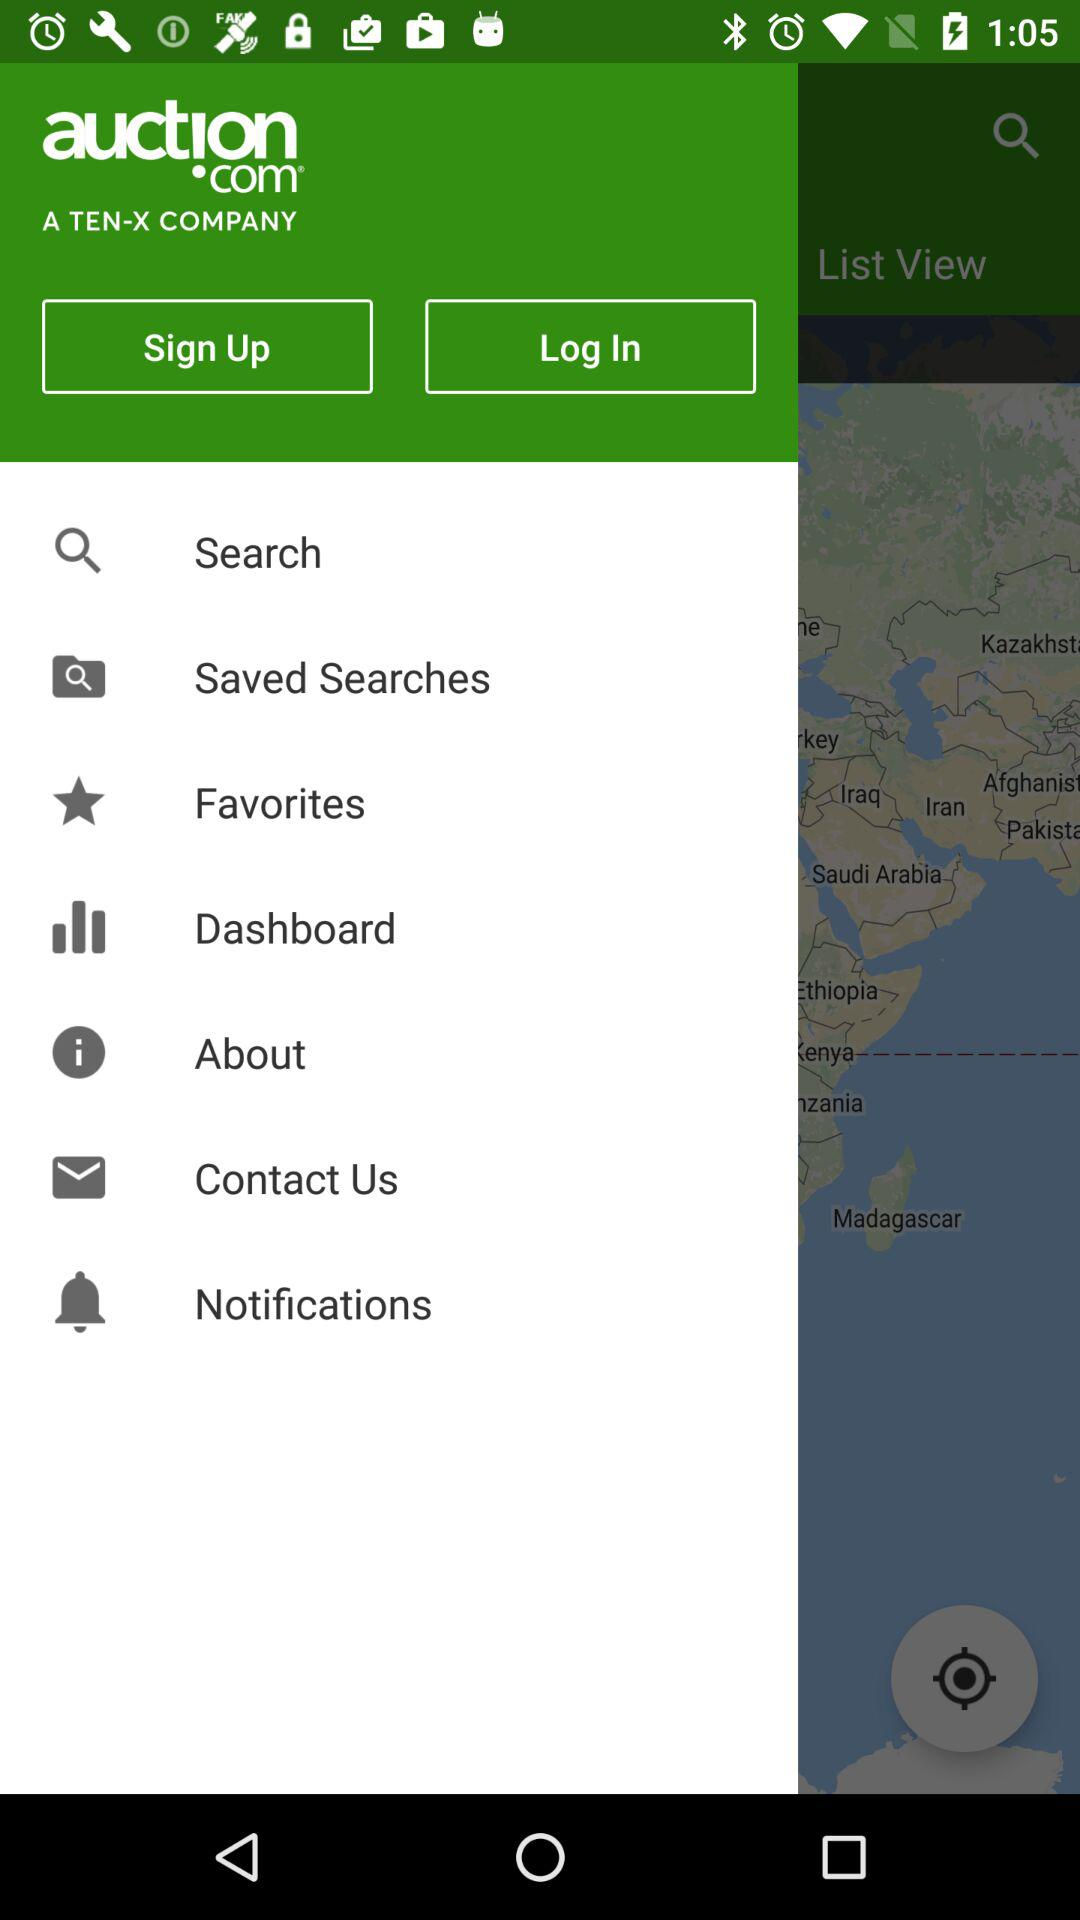What is the name of the application? The name of the application is "auction.com". 